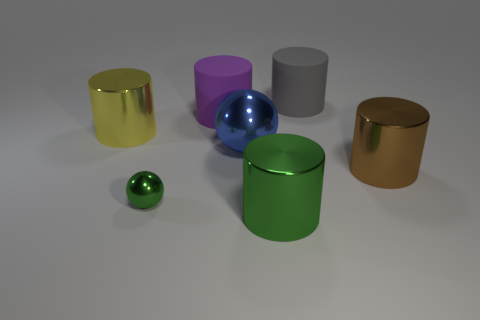Subtract 2 cylinders. How many cylinders are left? 3 Subtract all brown cylinders. How many cylinders are left? 4 Subtract all brown cylinders. How many cylinders are left? 4 Add 1 purple cylinders. How many objects exist? 8 Subtract all purple cylinders. Subtract all brown spheres. How many cylinders are left? 4 Subtract all cylinders. How many objects are left? 2 Subtract 0 gray spheres. How many objects are left? 7 Subtract all cyan blocks. Subtract all metallic cylinders. How many objects are left? 4 Add 2 large metal cylinders. How many large metal cylinders are left? 5 Add 7 large blue rubber spheres. How many large blue rubber spheres exist? 7 